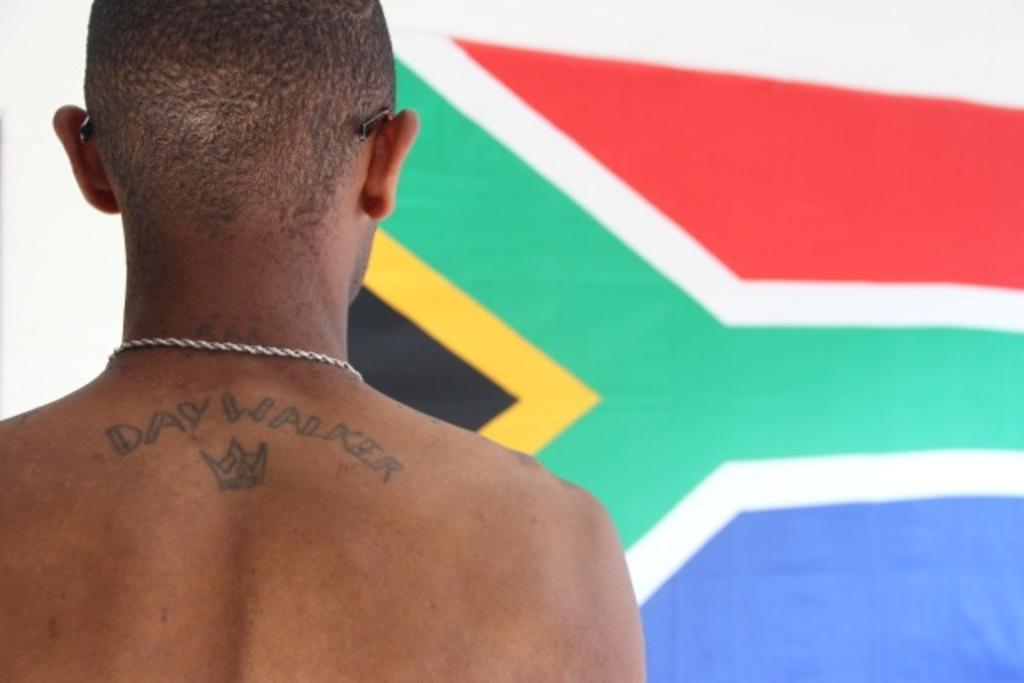What is present in the image? There is a person in the image. Can you describe any distinguishing features of the person? The person has a tattoo. What else can be seen in the image? There is a flag in the image. What type of bells can be heard ringing in the lunchroom in the image? There is no lunchroom or bells present in the image. 